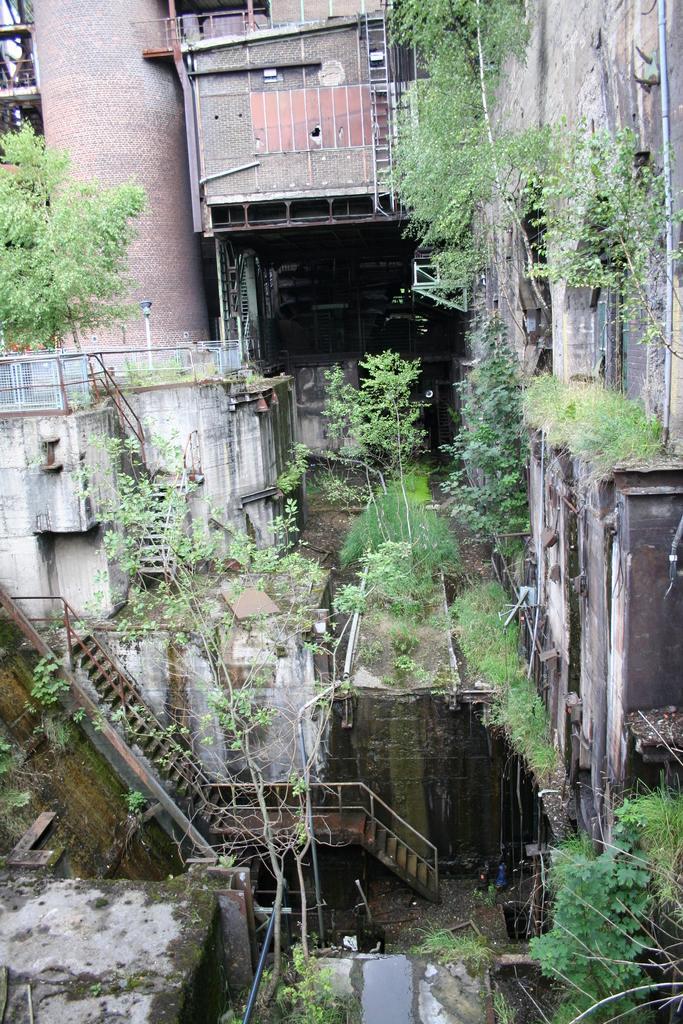Describe this image in one or two sentences. In the image we can see some staircases and trees and buildings. 